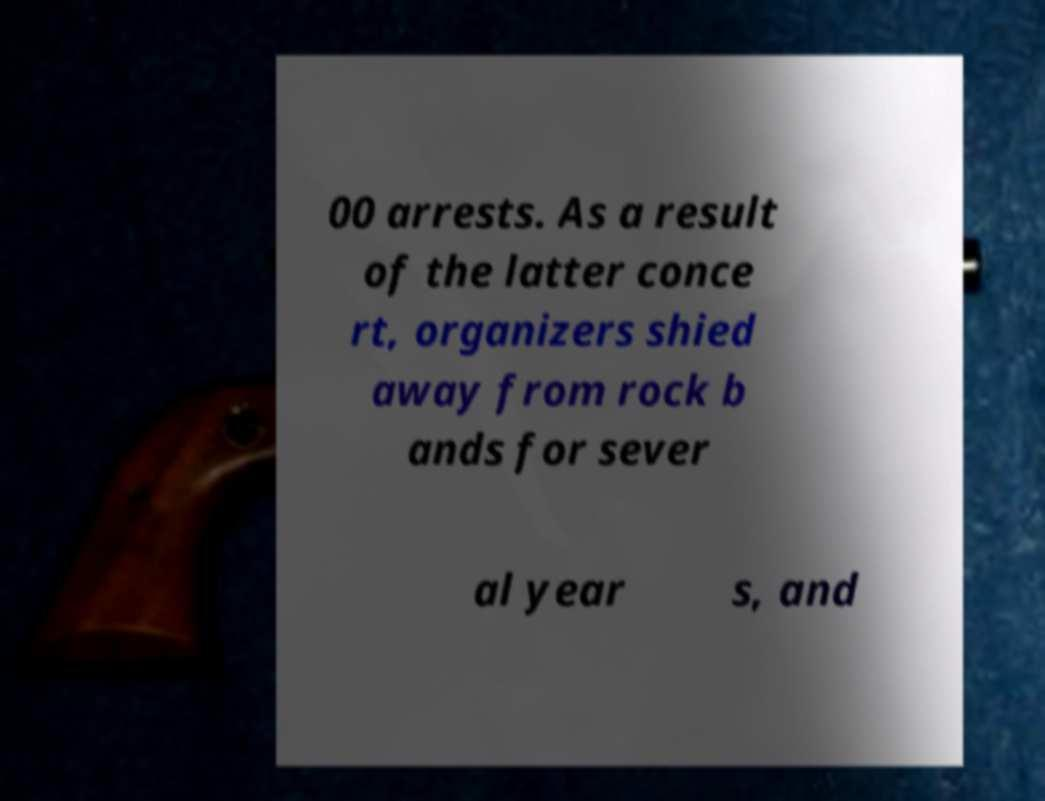There's text embedded in this image that I need extracted. Can you transcribe it verbatim? 00 arrests. As a result of the latter conce rt, organizers shied away from rock b ands for sever al year s, and 